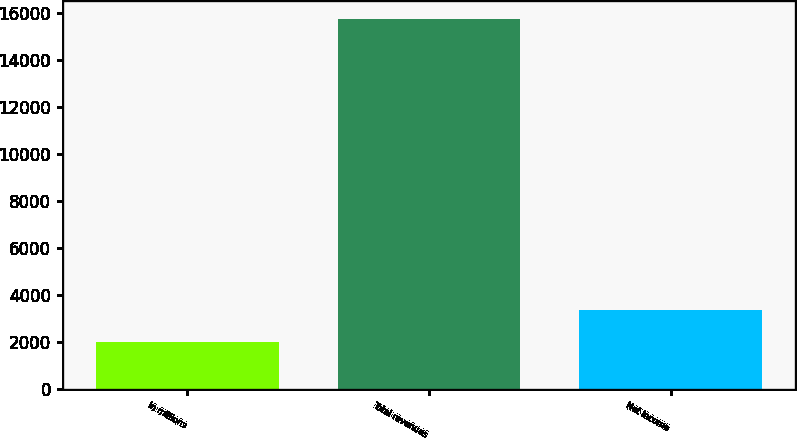Convert chart. <chart><loc_0><loc_0><loc_500><loc_500><bar_chart><fcel>In millions<fcel>Total revenues<fcel>Net income<nl><fcel>2012<fcel>15721<fcel>3382.9<nl></chart> 